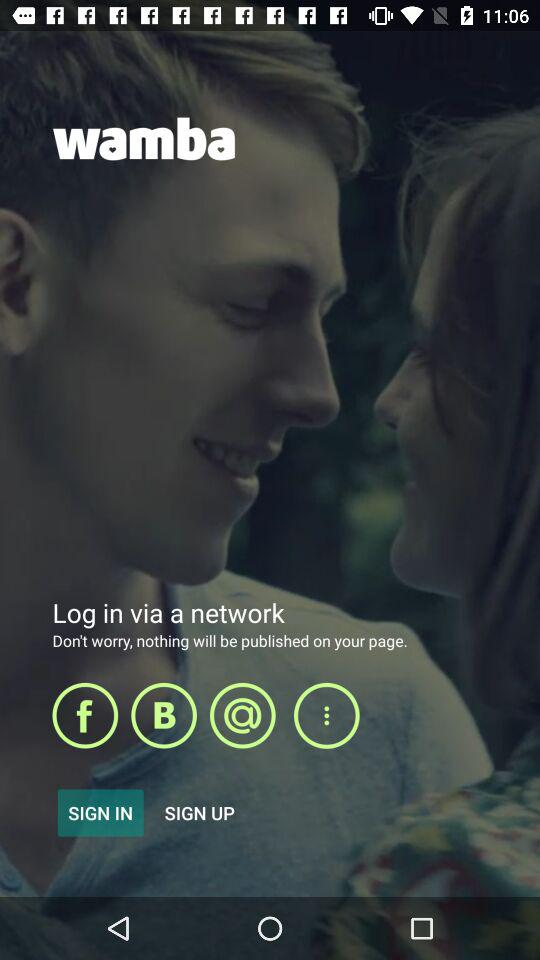What is the app title? The app title is "wamba". 